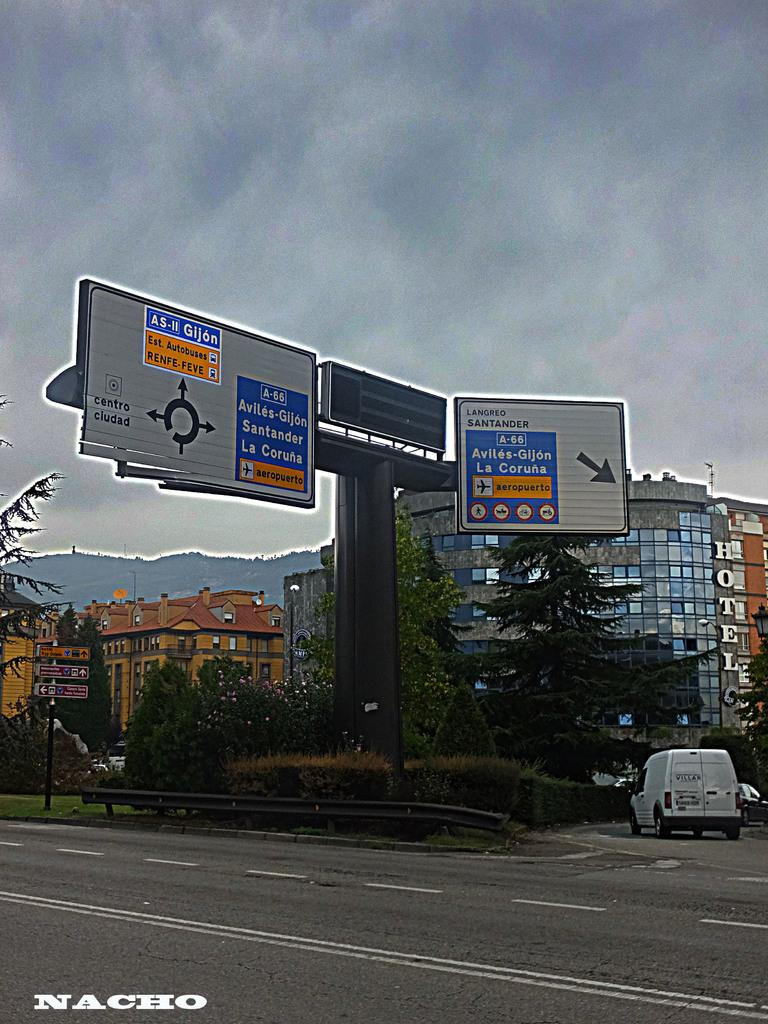<image>
Render a clear and concise summary of the photo. A street sign is showing that the airport is to the right. 